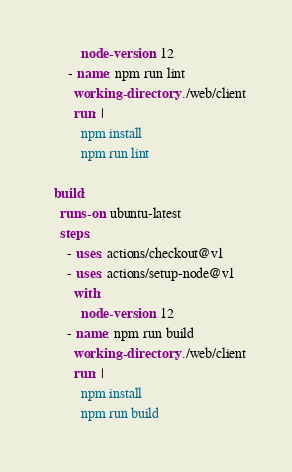Convert code to text. <code><loc_0><loc_0><loc_500><loc_500><_YAML_>          node-version: 12
      - name: npm run lint
        working-directory: ./web/client
        run: |
          npm install
          npm run lint

  build:
    runs-on: ubuntu-latest
    steps:
      - uses: actions/checkout@v1
      - uses: actions/setup-node@v1
        with:
          node-version: 12
      - name: npm run build
        working-directory: ./web/client
        run: |
          npm install
          npm run build
</code> 